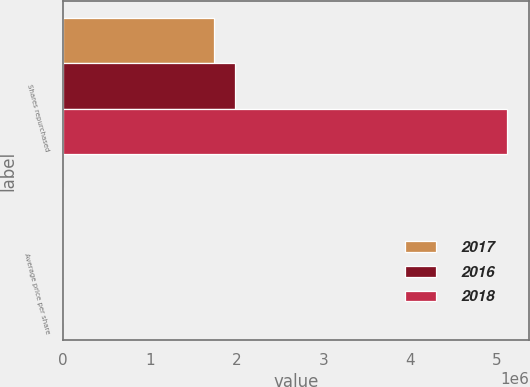Convert chart. <chart><loc_0><loc_0><loc_500><loc_500><stacked_bar_chart><ecel><fcel>Shares repurchased<fcel>Average price per share<nl><fcel>2017<fcel>1.73823e+06<fcel>172.59<nl><fcel>2016<fcel>1.97678e+06<fcel>133.9<nl><fcel>2018<fcel>5.12105e+06<fcel>108.87<nl></chart> 